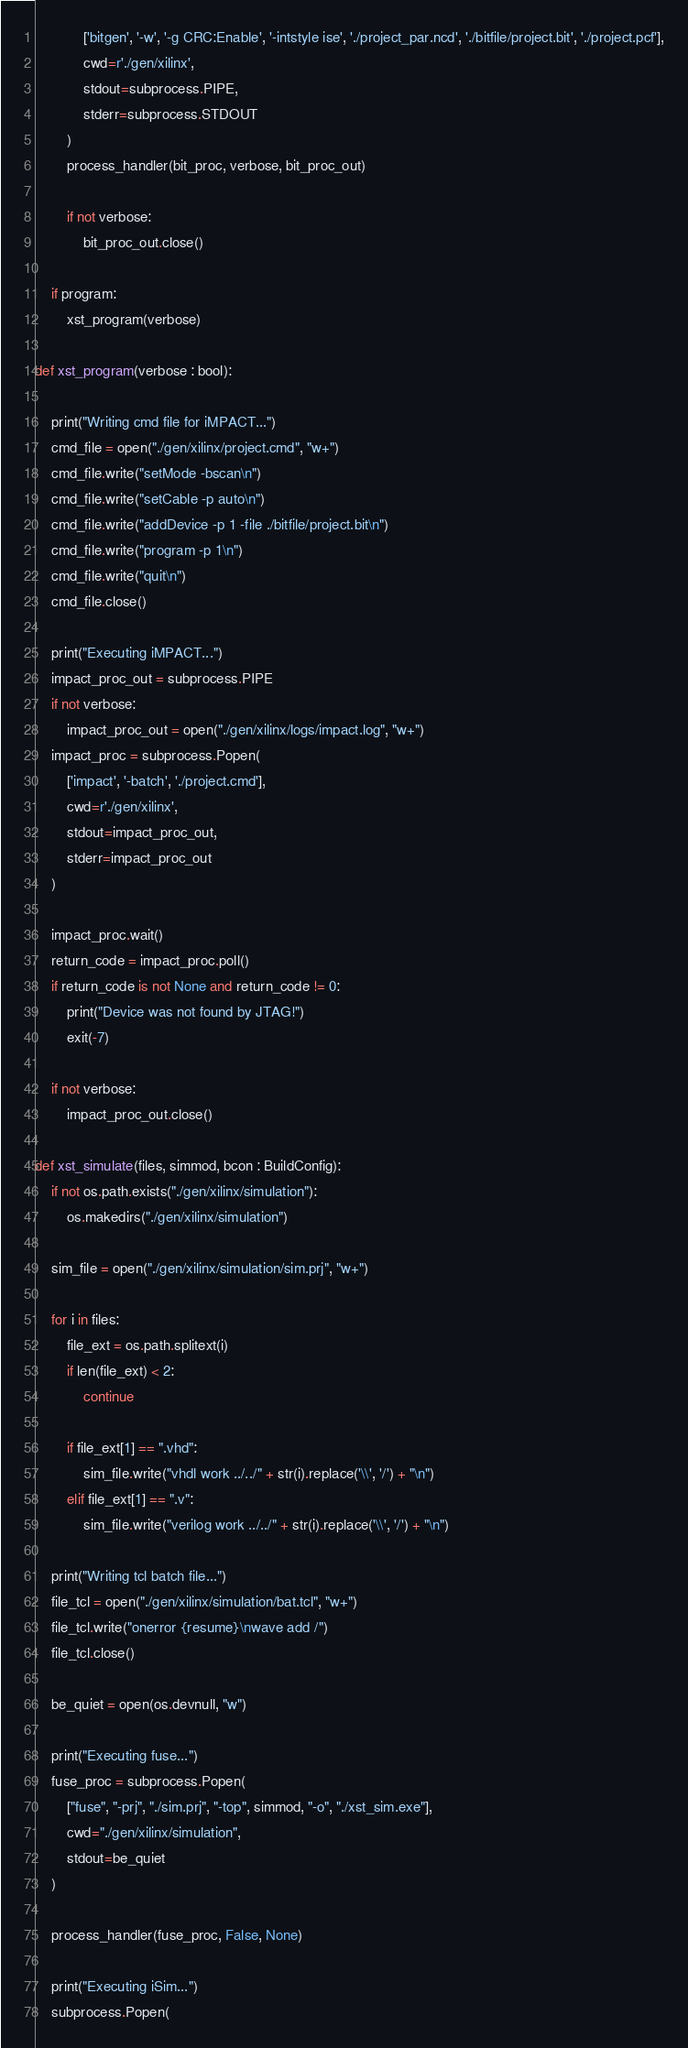Convert code to text. <code><loc_0><loc_0><loc_500><loc_500><_Python_>            ['bitgen', '-w', '-g CRC:Enable', '-intstyle ise', './project_par.ncd', './bitfile/project.bit', './project.pcf'],
            cwd=r'./gen/xilinx',
            stdout=subprocess.PIPE,
            stderr=subprocess.STDOUT
        )
        process_handler(bit_proc, verbose, bit_proc_out)

        if not verbose:
            bit_proc_out.close()

    if program:
        xst_program(verbose)

def xst_program(verbose : bool):

    print("Writing cmd file for iMPACT...")
    cmd_file = open("./gen/xilinx/project.cmd", "w+")
    cmd_file.write("setMode -bscan\n")
    cmd_file.write("setCable -p auto\n")
    cmd_file.write("addDevice -p 1 -file ./bitfile/project.bit\n")
    cmd_file.write("program -p 1\n")
    cmd_file.write("quit\n")
    cmd_file.close()

    print("Executing iMPACT...")
    impact_proc_out = subprocess.PIPE
    if not verbose:
        impact_proc_out = open("./gen/xilinx/logs/impact.log", "w+")
    impact_proc = subprocess.Popen(
        ['impact', '-batch', './project.cmd'],
        cwd=r'./gen/xilinx',
        stdout=impact_proc_out,
        stderr=impact_proc_out
    )

    impact_proc.wait()
    return_code = impact_proc.poll()
    if return_code is not None and return_code != 0:
        print("Device was not found by JTAG!")
        exit(-7)

    if not verbose:
        impact_proc_out.close()

def xst_simulate(files, simmod, bcon : BuildConfig):
    if not os.path.exists("./gen/xilinx/simulation"):
        os.makedirs("./gen/xilinx/simulation")

    sim_file = open("./gen/xilinx/simulation/sim.prj", "w+")

    for i in files:
        file_ext = os.path.splitext(i)
        if len(file_ext) < 2:
            continue

        if file_ext[1] == ".vhd":
            sim_file.write("vhdl work ../../" + str(i).replace('\\', '/') + "\n")
        elif file_ext[1] == ".v":
            sim_file.write("verilog work ../../" + str(i).replace('\\', '/') + "\n")

    print("Writing tcl batch file...")
    file_tcl = open("./gen/xilinx/simulation/bat.tcl", "w+")
    file_tcl.write("onerror {resume}\nwave add /")
    file_tcl.close()

    be_quiet = open(os.devnull, "w")

    print("Executing fuse...")
    fuse_proc = subprocess.Popen(
        ["fuse", "-prj", "./sim.prj", "-top", simmod, "-o", "./xst_sim.exe"],
        cwd="./gen/xilinx/simulation",
        stdout=be_quiet
    )

    process_handler(fuse_proc, False, None)

    print("Executing iSim...")
    subprocess.Popen(</code> 